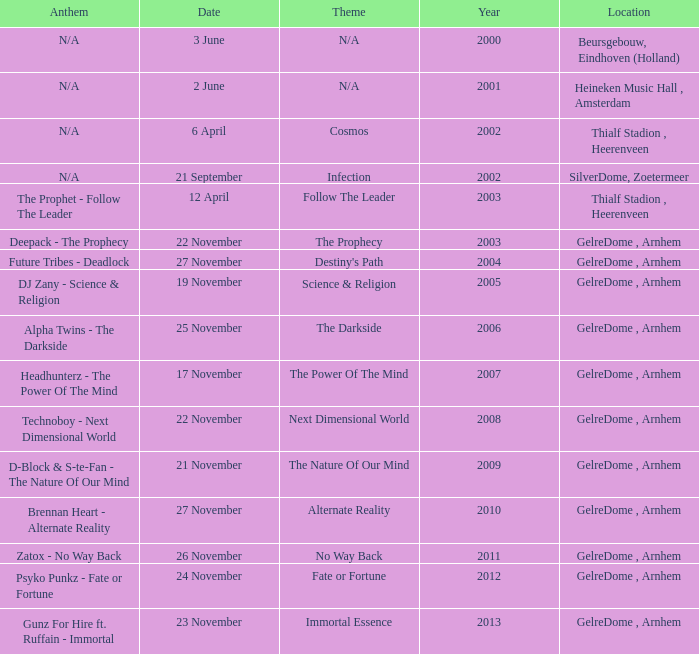What is the earliest year it was located in gelredome, arnhem, and a Anthem of technoboy - next dimensional world? 2008.0. 